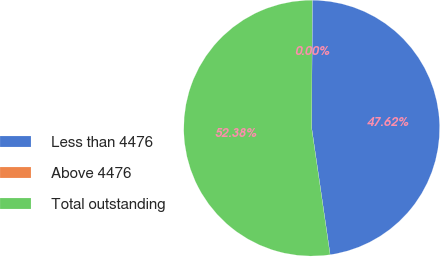<chart> <loc_0><loc_0><loc_500><loc_500><pie_chart><fcel>Less than 4476<fcel>Above 4476<fcel>Total outstanding<nl><fcel>47.62%<fcel>0.0%<fcel>52.38%<nl></chart> 